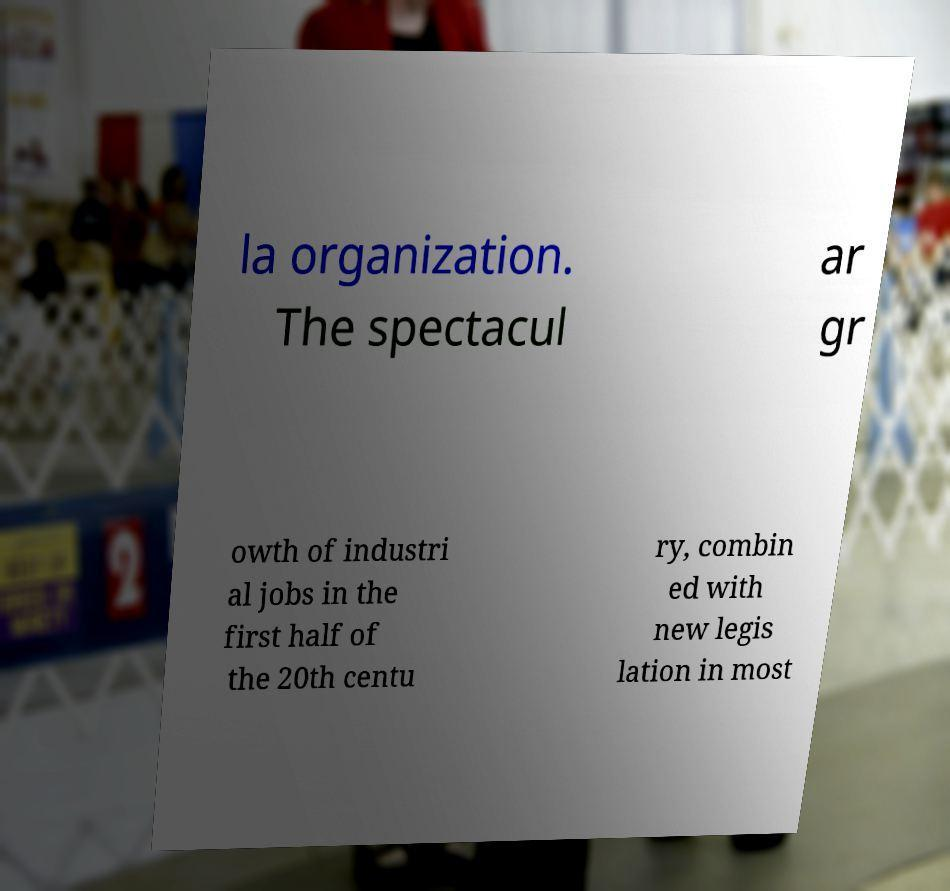What messages or text are displayed in this image? I need them in a readable, typed format. la organization. The spectacul ar gr owth of industri al jobs in the first half of the 20th centu ry, combin ed with new legis lation in most 